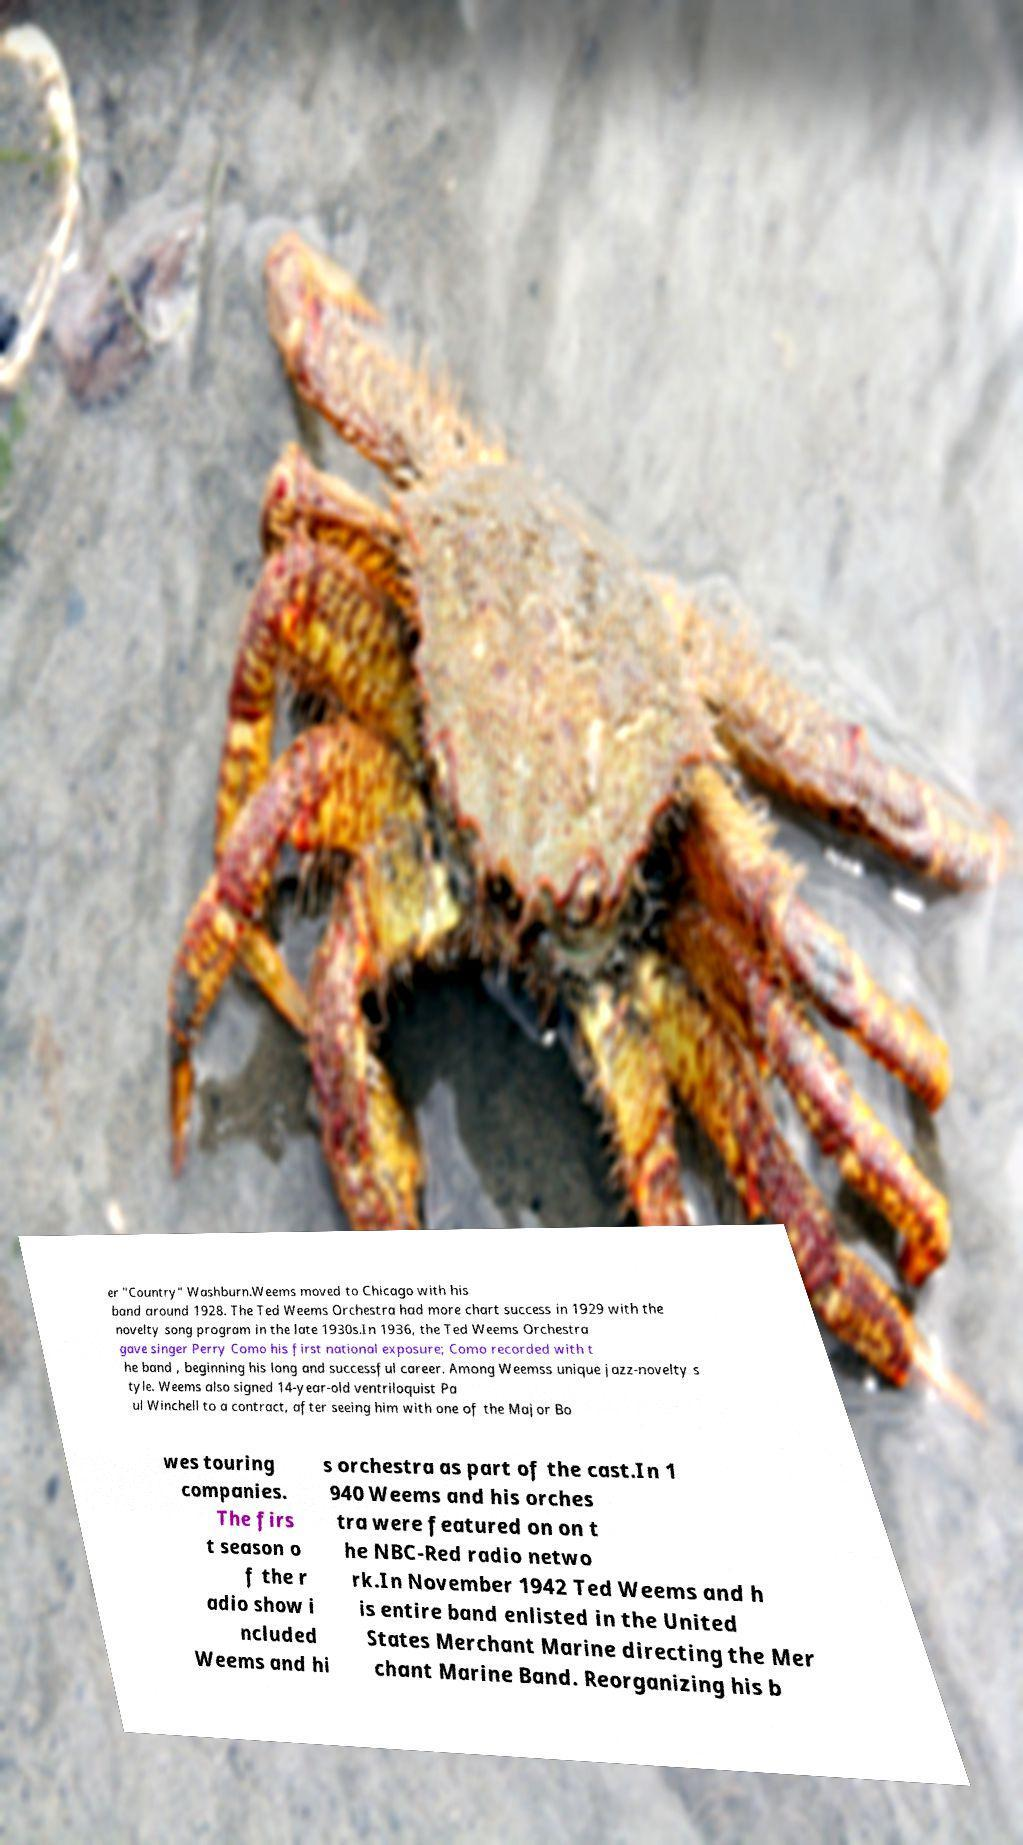Can you accurately transcribe the text from the provided image for me? er "Country" Washburn.Weems moved to Chicago with his band around 1928. The Ted Weems Orchestra had more chart success in 1929 with the novelty song program in the late 1930s.In 1936, the Ted Weems Orchestra gave singer Perry Como his first national exposure; Como recorded with t he band , beginning his long and successful career. Among Weemss unique jazz-novelty s tyle. Weems also signed 14-year-old ventriloquist Pa ul Winchell to a contract, after seeing him with one of the Major Bo wes touring companies. The firs t season o f the r adio show i ncluded Weems and hi s orchestra as part of the cast.In 1 940 Weems and his orches tra were featured on on t he NBC-Red radio netwo rk.In November 1942 Ted Weems and h is entire band enlisted in the United States Merchant Marine directing the Mer chant Marine Band. Reorganizing his b 